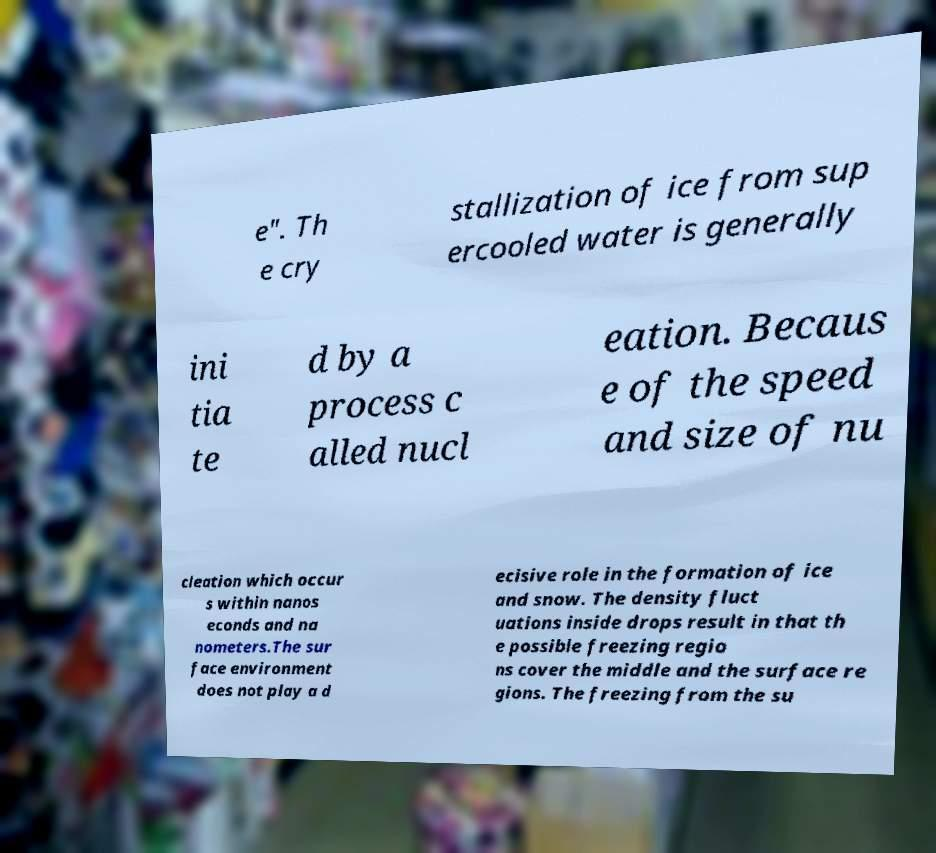For documentation purposes, I need the text within this image transcribed. Could you provide that? e". Th e cry stallization of ice from sup ercooled water is generally ini tia te d by a process c alled nucl eation. Becaus e of the speed and size of nu cleation which occur s within nanos econds and na nometers.The sur face environment does not play a d ecisive role in the formation of ice and snow. The density fluct uations inside drops result in that th e possible freezing regio ns cover the middle and the surface re gions. The freezing from the su 